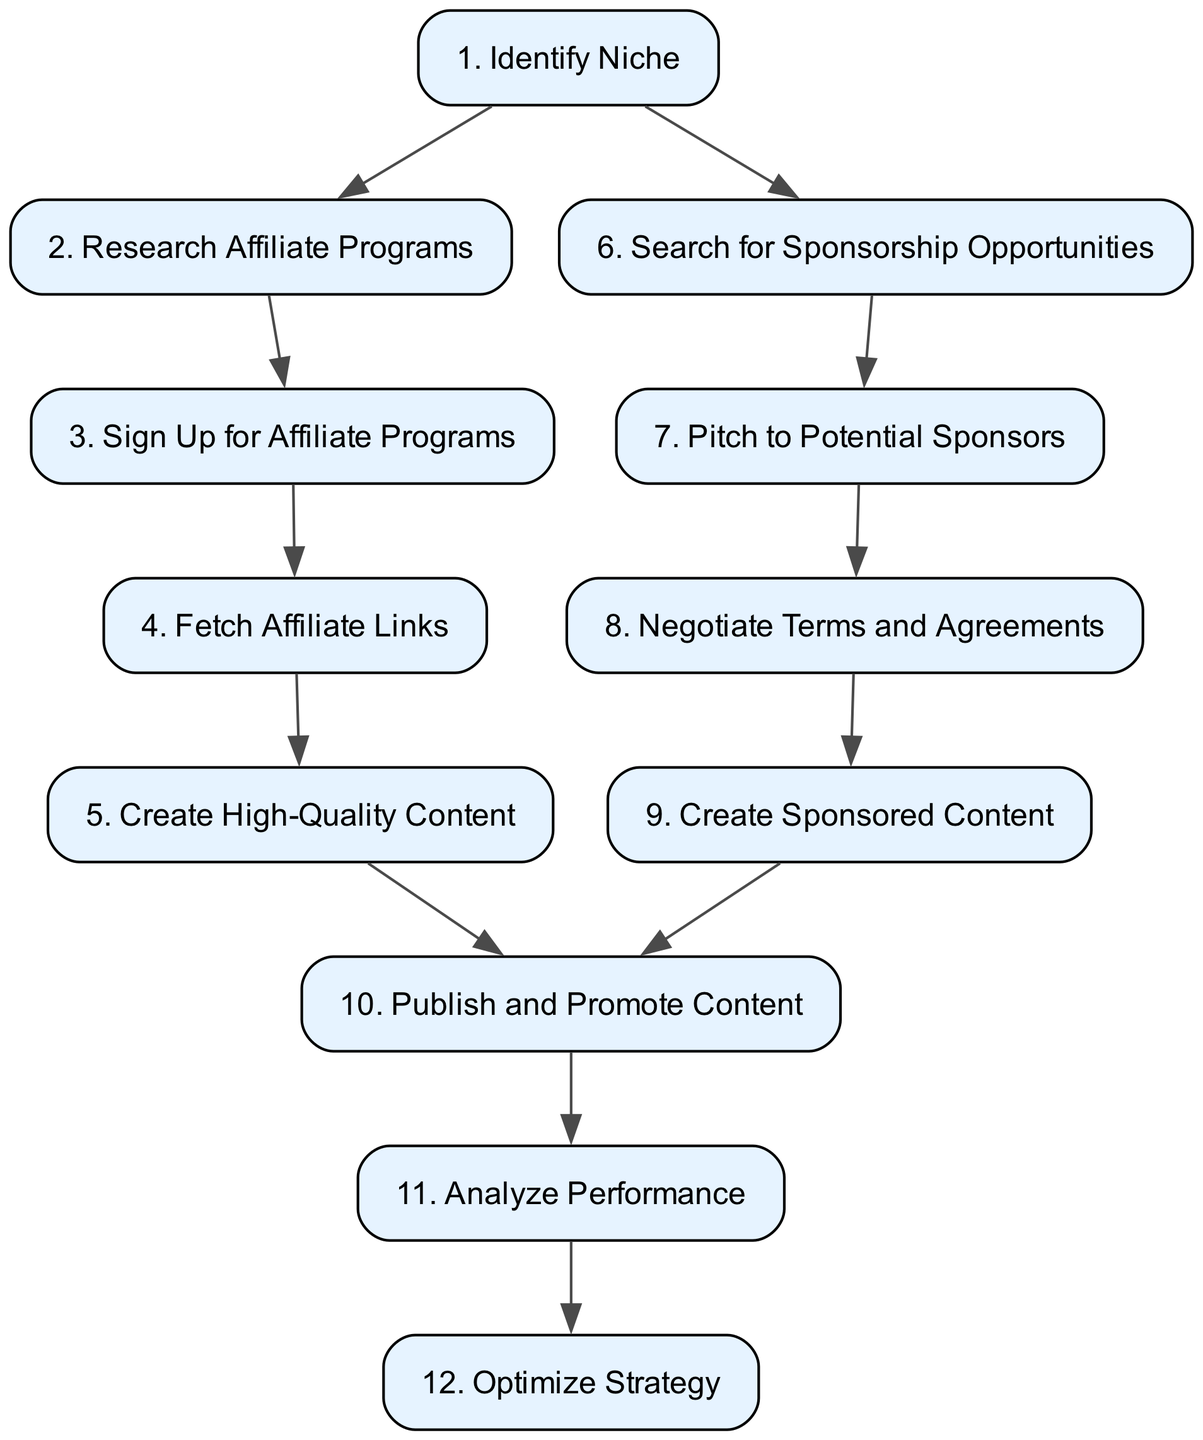What is the first step in monetizing a music blog? The first step listed in the diagram is to "Identify Niche." This is the initial action that sets the direction for the entire monetization process.
Answer: Identify Niche How many steps are involved in the monetization process? The diagram outlines a total of twelve steps involved in the monetization process of a music blog. Each step represents a key action required for successful monetization.
Answer: 12 What step involves registering for affiliate programs? According to the diagram, step three is where one "Sign Up for Affiliate Programs." This indicates the action of registering for affiliate programs relevant to the blog's niche.
Answer: Sign Up for Affiliate Programs What is the last step in the flowchart? The final step referenced in the diagram is to "Optimize Strategy." This reflects the importance of analyzing results and refining strategies based on performance.
Answer: Optimize Strategy Which step depends on collecting affiliate links? In the diagram, step five, which is "Create High-Quality Content," depends on step four, "Fetch Affiliate Links." This highlights the need for affiliate links to create relevant content.
Answer: Create High-Quality Content How many dependencies does step eight have? Step eight, which is "Negotiate Terms and Agreements," has one dependency, which is step seven, "Pitch to Potential Sponsors." This indicates that one must pitch to sponsors before negotiating terms.
Answer: 1 What action follows creating sponsored content? According to the diagram, after completing step nine, "Create Sponsored Content," the next action is to "Publish and Promote Content," which combines both the affiliate and sponsored content strategies.
Answer: Publish and Promote Content Which steps require analyzing performance before optimizing strategy? Steps ten and eleven, "Publish and Promote Content" and "Analyze Performance," need to be completed before proceeding to step twelve, "Optimize Strategy." The performance analysis is crucial before any optimization.
Answer: Publish and Promote Content, Analyze Performance What step is immediately after creating high-quality content? The step that follows "Create High-Quality Content" (step five) is "Search for Sponsorship Opportunities" (step six). This indicates that creating content and seeking sponsorship opportunities can be concurrent processes.
Answer: Search for Sponsorship Opportunities 